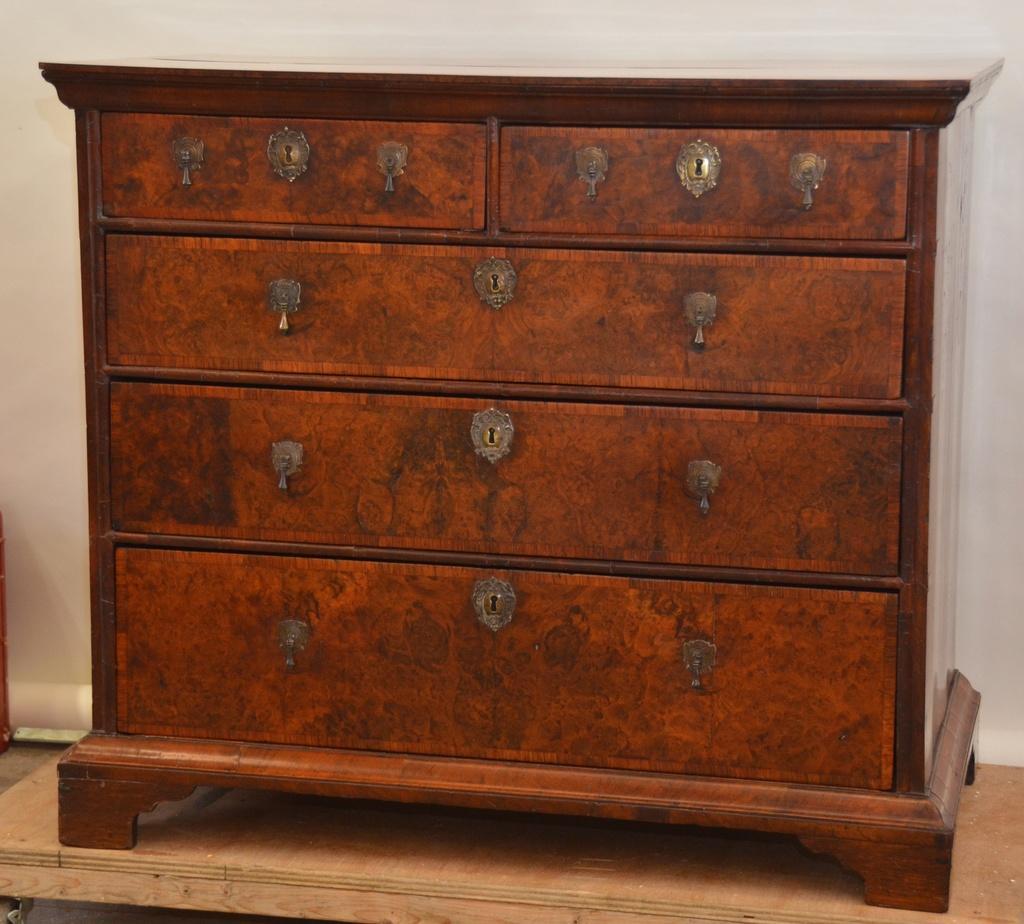In one or two sentences, can you explain what this image depicts? This image is taken indoors. In the background there is a wall. At the bottom of the image there is a floor. In the middle of the image there is a cupboard on the table. The cupboard is brown in color. 